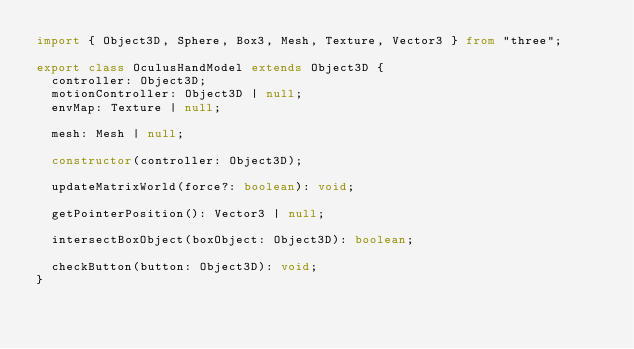Convert code to text. <code><loc_0><loc_0><loc_500><loc_500><_TypeScript_>import { Object3D, Sphere, Box3, Mesh, Texture, Vector3 } from "three";

export class OculusHandModel extends Object3D {
  controller: Object3D;
  motionController: Object3D | null;
  envMap: Texture | null;

  mesh: Mesh | null;

  constructor(controller: Object3D);

  updateMatrixWorld(force?: boolean): void;

  getPointerPosition(): Vector3 | null;

  intersectBoxObject(boxObject: Object3D): boolean;

  checkButton(button: Object3D): void;
}
</code> 